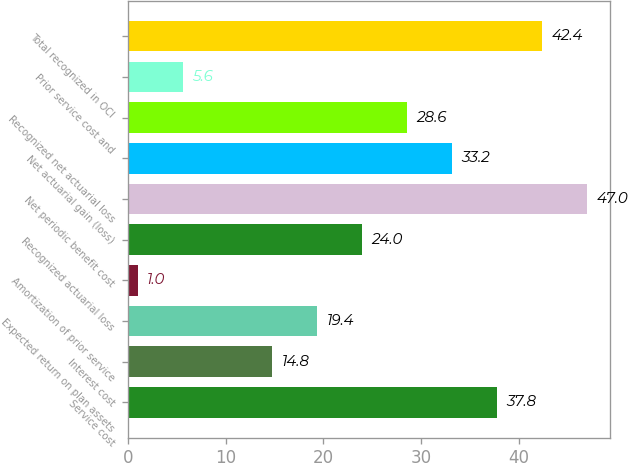Convert chart. <chart><loc_0><loc_0><loc_500><loc_500><bar_chart><fcel>Service cost<fcel>Interest cost<fcel>Expected return on plan assets<fcel>Amortization of prior service<fcel>Recognized actuarial loss<fcel>Net periodic benefit cost<fcel>Net actuarial gain (loss)<fcel>Recognized net actuarial loss<fcel>Prior service cost and<fcel>Total recognized in OCI<nl><fcel>37.8<fcel>14.8<fcel>19.4<fcel>1<fcel>24<fcel>47<fcel>33.2<fcel>28.6<fcel>5.6<fcel>42.4<nl></chart> 